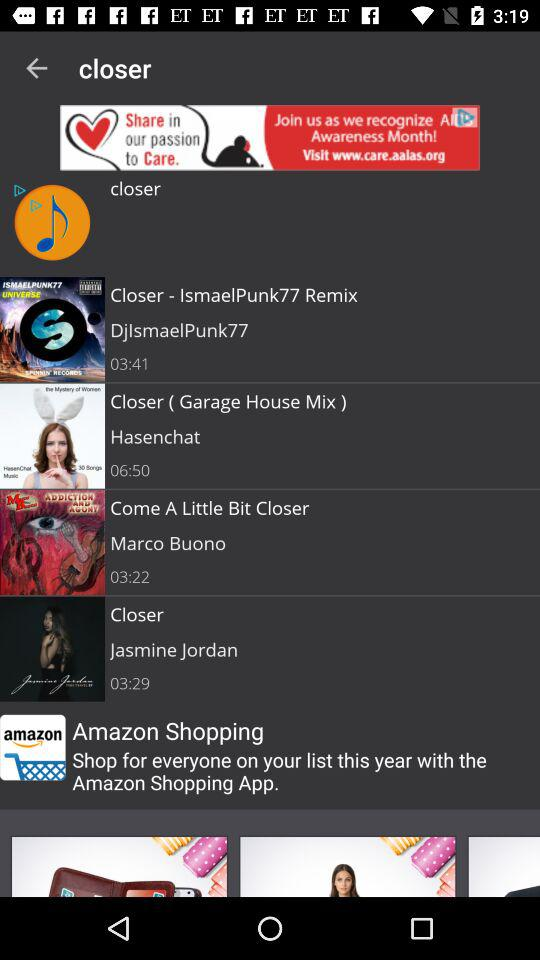What can you tell me about the user interface design of the app shown in the image? The app shown in the image features a straightforward and user-friendly interface, focused on accessibility and ease of use. It uses a dark theme that helps highlight the album covers and song titles. The main buttons are clearly placed for playing music, and tabs at the bottom suggest different functionalities like search and shopping, reflecting a multipurpose app design. 